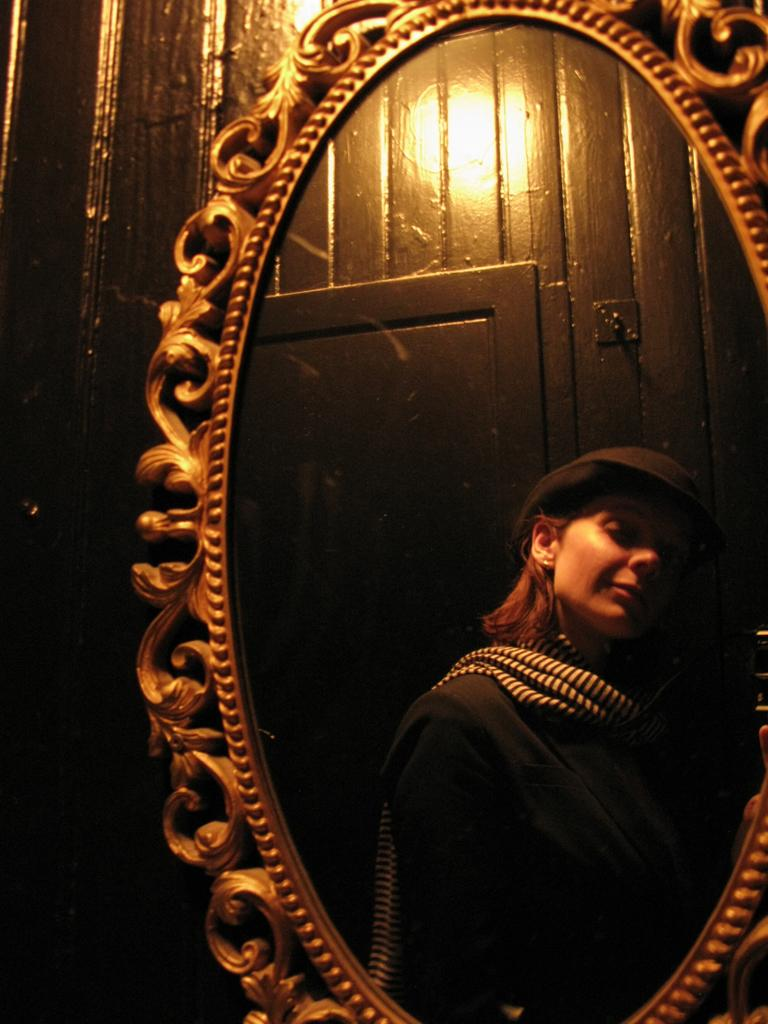Who is present in the image? There is a woman in the image. What is the woman wearing on her head? The woman is wearing a hat. What object can be used for personal grooming or reflection in the image? There is a mirror in the image. What architectural feature is present in the image? There is a door in the image. Can you tell me how many horses are visible in the image? There are no horses present in the image. What type of holiday is being celebrated in the image? There is no indication of a holiday being celebrated in the image. 